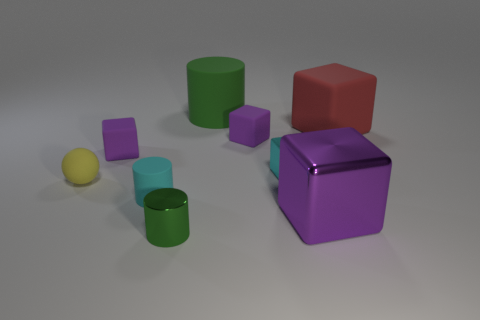What is the material of the cylinder that is the same size as the red rubber cube?
Your answer should be very brief. Rubber. Is the number of tiny green cylinders that are in front of the tiny green shiny cylinder the same as the number of metallic things in front of the purple shiny object?
Offer a very short reply. No. There is a purple matte thing that is right of the large green cylinder behind the big matte cube; what number of small green metal cylinders are in front of it?
Your response must be concise. 1. Does the big metal cube have the same color as the block to the left of the big matte cylinder?
Provide a succinct answer. Yes. What size is the red block that is made of the same material as the cyan cylinder?
Offer a terse response. Large. Are there more small cyan matte objects that are in front of the large green rubber cylinder than big yellow metal cylinders?
Your answer should be very brief. Yes. There is a cube in front of the small cyan metal cube that is in front of the thing to the right of the big purple object; what is its material?
Your answer should be very brief. Metal. Does the large green object have the same material as the cube to the right of the purple metal thing?
Your answer should be very brief. Yes. What is the material of the big purple object that is the same shape as the small cyan metallic object?
Offer a terse response. Metal. Are there more purple matte cubes behind the big purple metal block than large metallic objects left of the yellow matte ball?
Give a very brief answer. Yes. 